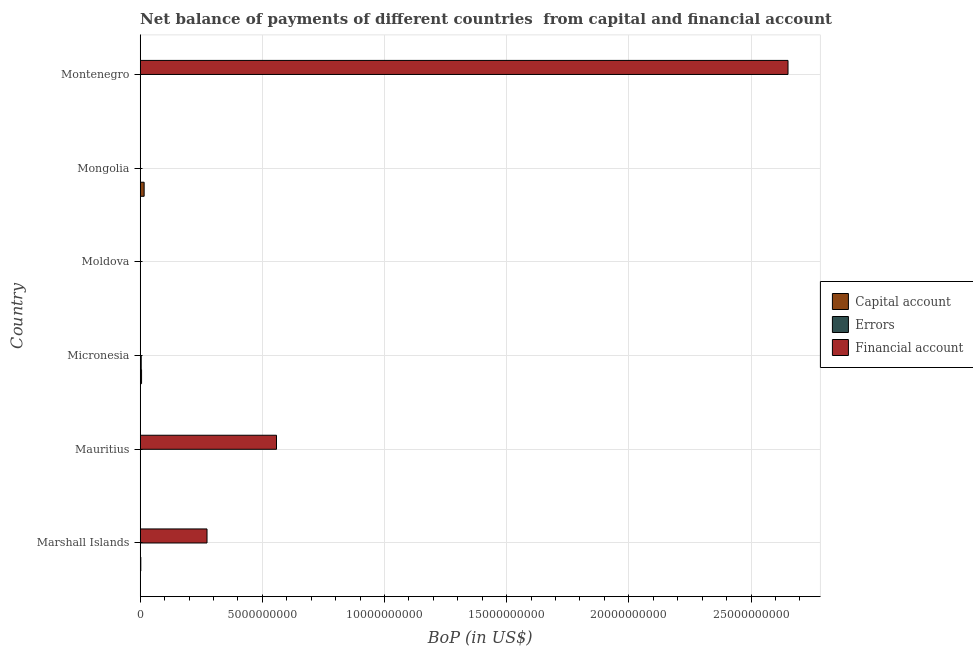How many different coloured bars are there?
Provide a short and direct response. 3. Are the number of bars per tick equal to the number of legend labels?
Your answer should be very brief. No. How many bars are there on the 2nd tick from the top?
Offer a very short reply. 1. How many bars are there on the 1st tick from the bottom?
Your response must be concise. 2. What is the label of the 3rd group of bars from the top?
Provide a succinct answer. Moldova. What is the amount of errors in Mongolia?
Provide a succinct answer. 0. Across all countries, what is the maximum amount of net capital account?
Ensure brevity in your answer.  1.60e+08. In which country was the amount of net capital account maximum?
Your answer should be compact. Mongolia. What is the total amount of financial account in the graph?
Your response must be concise. 3.48e+1. What is the difference between the amount of net capital account in Marshall Islands and that in Montenegro?
Your answer should be compact. 2.11e+07. What is the difference between the amount of financial account in Mauritius and the amount of errors in Micronesia?
Offer a terse response. 5.54e+09. What is the average amount of financial account per country?
Your response must be concise. 5.80e+09. What is the difference between the amount of net capital account and amount of errors in Micronesia?
Provide a short and direct response. 1.45e+07. In how many countries, is the amount of net capital account greater than 1000000000 US$?
Make the answer very short. 0. What is the ratio of the amount of financial account in Marshall Islands to that in Mauritius?
Provide a short and direct response. 0.49. Is the amount of net capital account in Marshall Islands less than that in Micronesia?
Provide a succinct answer. Yes. What is the difference between the highest and the second highest amount of net capital account?
Offer a terse response. 1.06e+08. What is the difference between the highest and the lowest amount of net capital account?
Make the answer very short. 1.60e+08. In how many countries, is the amount of financial account greater than the average amount of financial account taken over all countries?
Give a very brief answer. 1. Is it the case that in every country, the sum of the amount of net capital account and amount of errors is greater than the amount of financial account?
Offer a terse response. No. Are the values on the major ticks of X-axis written in scientific E-notation?
Give a very brief answer. No. Does the graph contain any zero values?
Provide a short and direct response. Yes. Does the graph contain grids?
Offer a terse response. Yes. Where does the legend appear in the graph?
Ensure brevity in your answer.  Center right. What is the title of the graph?
Your answer should be compact. Net balance of payments of different countries  from capital and financial account. Does "Natural gas sources" appear as one of the legend labels in the graph?
Your answer should be compact. No. What is the label or title of the X-axis?
Make the answer very short. BoP (in US$). What is the label or title of the Y-axis?
Your answer should be very brief. Country. What is the BoP (in US$) of Capital account in Marshall Islands?
Provide a succinct answer. 2.38e+07. What is the BoP (in US$) in Financial account in Marshall Islands?
Provide a short and direct response. 2.73e+09. What is the BoP (in US$) of Capital account in Mauritius?
Provide a short and direct response. 0. What is the BoP (in US$) of Financial account in Mauritius?
Provide a short and direct response. 5.58e+09. What is the BoP (in US$) in Capital account in Micronesia?
Offer a terse response. 5.49e+07. What is the BoP (in US$) in Errors in Micronesia?
Give a very brief answer. 4.04e+07. What is the BoP (in US$) of Capital account in Moldova?
Your answer should be compact. 6.00e+04. What is the BoP (in US$) of Errors in Moldova?
Ensure brevity in your answer.  0. What is the BoP (in US$) in Financial account in Moldova?
Make the answer very short. 0. What is the BoP (in US$) of Capital account in Mongolia?
Your response must be concise. 1.60e+08. What is the BoP (in US$) in Capital account in Montenegro?
Keep it short and to the point. 2.66e+06. What is the BoP (in US$) in Financial account in Montenegro?
Provide a succinct answer. 2.65e+1. Across all countries, what is the maximum BoP (in US$) in Capital account?
Keep it short and to the point. 1.60e+08. Across all countries, what is the maximum BoP (in US$) of Errors?
Offer a terse response. 4.04e+07. Across all countries, what is the maximum BoP (in US$) in Financial account?
Provide a succinct answer. 2.65e+1. Across all countries, what is the minimum BoP (in US$) of Capital account?
Your answer should be very brief. 0. Across all countries, what is the minimum BoP (in US$) of Financial account?
Make the answer very short. 0. What is the total BoP (in US$) in Capital account in the graph?
Provide a succinct answer. 2.42e+08. What is the total BoP (in US$) of Errors in the graph?
Give a very brief answer. 4.04e+07. What is the total BoP (in US$) of Financial account in the graph?
Make the answer very short. 3.48e+1. What is the difference between the BoP (in US$) of Financial account in Marshall Islands and that in Mauritius?
Offer a terse response. -2.84e+09. What is the difference between the BoP (in US$) of Capital account in Marshall Islands and that in Micronesia?
Provide a succinct answer. -3.11e+07. What is the difference between the BoP (in US$) of Capital account in Marshall Islands and that in Moldova?
Provide a short and direct response. 2.37e+07. What is the difference between the BoP (in US$) in Capital account in Marshall Islands and that in Mongolia?
Keep it short and to the point. -1.37e+08. What is the difference between the BoP (in US$) in Capital account in Marshall Islands and that in Montenegro?
Give a very brief answer. 2.11e+07. What is the difference between the BoP (in US$) of Financial account in Marshall Islands and that in Montenegro?
Provide a short and direct response. -2.38e+1. What is the difference between the BoP (in US$) of Financial account in Mauritius and that in Montenegro?
Offer a very short reply. -2.09e+1. What is the difference between the BoP (in US$) in Capital account in Micronesia and that in Moldova?
Offer a very short reply. 5.48e+07. What is the difference between the BoP (in US$) of Capital account in Micronesia and that in Mongolia?
Offer a very short reply. -1.06e+08. What is the difference between the BoP (in US$) in Capital account in Micronesia and that in Montenegro?
Your response must be concise. 5.22e+07. What is the difference between the BoP (in US$) in Capital account in Moldova and that in Mongolia?
Offer a very short reply. -1.60e+08. What is the difference between the BoP (in US$) of Capital account in Moldova and that in Montenegro?
Your answer should be compact. -2.60e+06. What is the difference between the BoP (in US$) of Capital account in Mongolia and that in Montenegro?
Offer a terse response. 1.58e+08. What is the difference between the BoP (in US$) in Capital account in Marshall Islands and the BoP (in US$) in Financial account in Mauritius?
Your answer should be very brief. -5.55e+09. What is the difference between the BoP (in US$) of Capital account in Marshall Islands and the BoP (in US$) of Errors in Micronesia?
Offer a very short reply. -1.66e+07. What is the difference between the BoP (in US$) of Capital account in Marshall Islands and the BoP (in US$) of Financial account in Montenegro?
Offer a very short reply. -2.65e+1. What is the difference between the BoP (in US$) in Capital account in Micronesia and the BoP (in US$) in Financial account in Montenegro?
Your answer should be very brief. -2.65e+1. What is the difference between the BoP (in US$) in Errors in Micronesia and the BoP (in US$) in Financial account in Montenegro?
Provide a succinct answer. -2.65e+1. What is the difference between the BoP (in US$) in Capital account in Moldova and the BoP (in US$) in Financial account in Montenegro?
Provide a succinct answer. -2.65e+1. What is the difference between the BoP (in US$) of Capital account in Mongolia and the BoP (in US$) of Financial account in Montenegro?
Offer a terse response. -2.64e+1. What is the average BoP (in US$) in Capital account per country?
Your answer should be compact. 4.03e+07. What is the average BoP (in US$) of Errors per country?
Make the answer very short. 6.73e+06. What is the average BoP (in US$) of Financial account per country?
Make the answer very short. 5.80e+09. What is the difference between the BoP (in US$) of Capital account and BoP (in US$) of Financial account in Marshall Islands?
Make the answer very short. -2.71e+09. What is the difference between the BoP (in US$) of Capital account and BoP (in US$) of Errors in Micronesia?
Your response must be concise. 1.45e+07. What is the difference between the BoP (in US$) in Capital account and BoP (in US$) in Financial account in Montenegro?
Make the answer very short. -2.65e+1. What is the ratio of the BoP (in US$) in Financial account in Marshall Islands to that in Mauritius?
Your answer should be compact. 0.49. What is the ratio of the BoP (in US$) in Capital account in Marshall Islands to that in Micronesia?
Your answer should be compact. 0.43. What is the ratio of the BoP (in US$) in Capital account in Marshall Islands to that in Moldova?
Your answer should be very brief. 396.82. What is the ratio of the BoP (in US$) of Capital account in Marshall Islands to that in Mongolia?
Offer a very short reply. 0.15. What is the ratio of the BoP (in US$) in Capital account in Marshall Islands to that in Montenegro?
Offer a terse response. 8.94. What is the ratio of the BoP (in US$) of Financial account in Marshall Islands to that in Montenegro?
Offer a terse response. 0.1. What is the ratio of the BoP (in US$) in Financial account in Mauritius to that in Montenegro?
Offer a very short reply. 0.21. What is the ratio of the BoP (in US$) in Capital account in Micronesia to that in Moldova?
Your response must be concise. 914.76. What is the ratio of the BoP (in US$) of Capital account in Micronesia to that in Mongolia?
Offer a very short reply. 0.34. What is the ratio of the BoP (in US$) of Capital account in Micronesia to that in Montenegro?
Offer a very short reply. 20.61. What is the ratio of the BoP (in US$) of Capital account in Moldova to that in Montenegro?
Make the answer very short. 0.02. What is the ratio of the BoP (in US$) of Capital account in Mongolia to that in Montenegro?
Provide a succinct answer. 60.28. What is the difference between the highest and the second highest BoP (in US$) in Capital account?
Give a very brief answer. 1.06e+08. What is the difference between the highest and the second highest BoP (in US$) in Financial account?
Provide a succinct answer. 2.09e+1. What is the difference between the highest and the lowest BoP (in US$) of Capital account?
Your answer should be very brief. 1.60e+08. What is the difference between the highest and the lowest BoP (in US$) in Errors?
Offer a very short reply. 4.04e+07. What is the difference between the highest and the lowest BoP (in US$) in Financial account?
Give a very brief answer. 2.65e+1. 